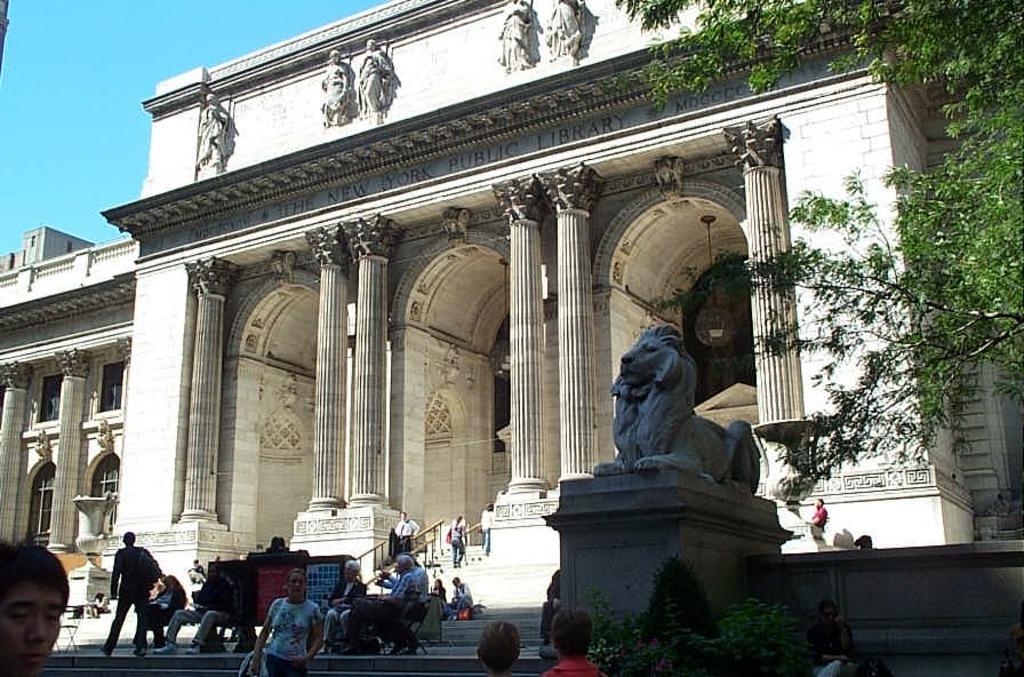Please provide a concise description of this image. We can see people and we can see statue on surface and plant. In the background we can see pillars,building,statues on the wall and sky in blue color. 